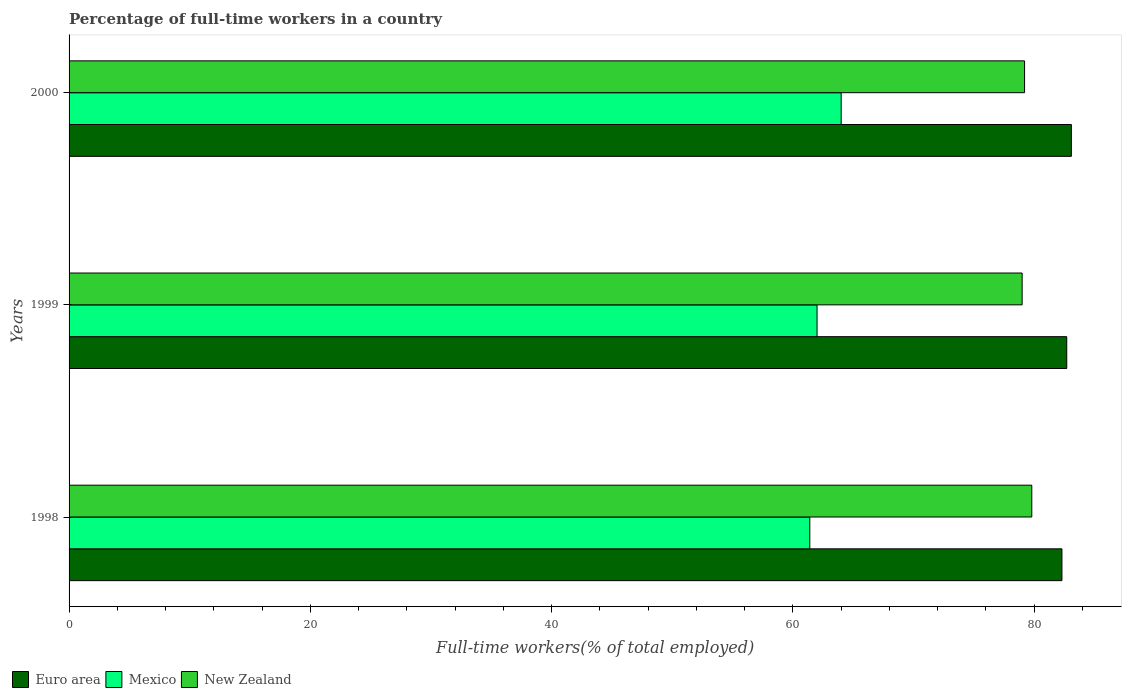Are the number of bars per tick equal to the number of legend labels?
Ensure brevity in your answer.  Yes. How many bars are there on the 3rd tick from the top?
Provide a short and direct response. 3. How many bars are there on the 2nd tick from the bottom?
Offer a very short reply. 3. What is the label of the 3rd group of bars from the top?
Ensure brevity in your answer.  1998. In how many cases, is the number of bars for a given year not equal to the number of legend labels?
Provide a short and direct response. 0. What is the percentage of full-time workers in New Zealand in 2000?
Provide a short and direct response. 79.2. Across all years, what is the maximum percentage of full-time workers in Euro area?
Your answer should be very brief. 83.08. Across all years, what is the minimum percentage of full-time workers in Mexico?
Your answer should be compact. 61.4. In which year was the percentage of full-time workers in New Zealand maximum?
Your answer should be compact. 1998. In which year was the percentage of full-time workers in Euro area minimum?
Your answer should be compact. 1998. What is the total percentage of full-time workers in Euro area in the graph?
Keep it short and to the point. 248.08. What is the difference between the percentage of full-time workers in Mexico in 1998 and that in 1999?
Ensure brevity in your answer.  -0.6. What is the difference between the percentage of full-time workers in Euro area in 2000 and the percentage of full-time workers in Mexico in 1999?
Keep it short and to the point. 21.08. What is the average percentage of full-time workers in New Zealand per year?
Ensure brevity in your answer.  79.33. In the year 1999, what is the difference between the percentage of full-time workers in Euro area and percentage of full-time workers in New Zealand?
Make the answer very short. 3.7. What is the ratio of the percentage of full-time workers in Euro area in 1998 to that in 2000?
Provide a succinct answer. 0.99. What is the difference between the highest and the second highest percentage of full-time workers in New Zealand?
Your answer should be very brief. 0.6. What is the difference between the highest and the lowest percentage of full-time workers in New Zealand?
Offer a terse response. 0.8. Is the sum of the percentage of full-time workers in Mexico in 1998 and 1999 greater than the maximum percentage of full-time workers in Euro area across all years?
Your response must be concise. Yes. Are all the bars in the graph horizontal?
Offer a terse response. Yes. How many years are there in the graph?
Offer a very short reply. 3. Does the graph contain any zero values?
Offer a terse response. No. Where does the legend appear in the graph?
Offer a terse response. Bottom left. What is the title of the graph?
Offer a terse response. Percentage of full-time workers in a country. Does "Euro area" appear as one of the legend labels in the graph?
Your response must be concise. Yes. What is the label or title of the X-axis?
Ensure brevity in your answer.  Full-time workers(% of total employed). What is the Full-time workers(% of total employed) of Euro area in 1998?
Your answer should be very brief. 82.3. What is the Full-time workers(% of total employed) in Mexico in 1998?
Provide a short and direct response. 61.4. What is the Full-time workers(% of total employed) in New Zealand in 1998?
Your answer should be very brief. 79.8. What is the Full-time workers(% of total employed) of Euro area in 1999?
Your answer should be very brief. 82.7. What is the Full-time workers(% of total employed) in New Zealand in 1999?
Your answer should be very brief. 79. What is the Full-time workers(% of total employed) of Euro area in 2000?
Your response must be concise. 83.08. What is the Full-time workers(% of total employed) in Mexico in 2000?
Give a very brief answer. 64. What is the Full-time workers(% of total employed) in New Zealand in 2000?
Your answer should be compact. 79.2. Across all years, what is the maximum Full-time workers(% of total employed) in Euro area?
Your response must be concise. 83.08. Across all years, what is the maximum Full-time workers(% of total employed) in Mexico?
Make the answer very short. 64. Across all years, what is the maximum Full-time workers(% of total employed) of New Zealand?
Offer a very short reply. 79.8. Across all years, what is the minimum Full-time workers(% of total employed) in Euro area?
Your response must be concise. 82.3. Across all years, what is the minimum Full-time workers(% of total employed) in Mexico?
Your response must be concise. 61.4. Across all years, what is the minimum Full-time workers(% of total employed) in New Zealand?
Provide a short and direct response. 79. What is the total Full-time workers(% of total employed) of Euro area in the graph?
Make the answer very short. 248.08. What is the total Full-time workers(% of total employed) of Mexico in the graph?
Your answer should be very brief. 187.4. What is the total Full-time workers(% of total employed) of New Zealand in the graph?
Give a very brief answer. 238. What is the difference between the Full-time workers(% of total employed) of Euro area in 1998 and that in 1999?
Ensure brevity in your answer.  -0.4. What is the difference between the Full-time workers(% of total employed) in New Zealand in 1998 and that in 1999?
Your answer should be very brief. 0.8. What is the difference between the Full-time workers(% of total employed) of Euro area in 1998 and that in 2000?
Your answer should be compact. -0.78. What is the difference between the Full-time workers(% of total employed) in Mexico in 1998 and that in 2000?
Your answer should be very brief. -2.6. What is the difference between the Full-time workers(% of total employed) in New Zealand in 1998 and that in 2000?
Provide a succinct answer. 0.6. What is the difference between the Full-time workers(% of total employed) of Euro area in 1999 and that in 2000?
Provide a succinct answer. -0.38. What is the difference between the Full-time workers(% of total employed) in New Zealand in 1999 and that in 2000?
Offer a terse response. -0.2. What is the difference between the Full-time workers(% of total employed) in Euro area in 1998 and the Full-time workers(% of total employed) in Mexico in 1999?
Your answer should be very brief. 20.3. What is the difference between the Full-time workers(% of total employed) in Euro area in 1998 and the Full-time workers(% of total employed) in New Zealand in 1999?
Give a very brief answer. 3.3. What is the difference between the Full-time workers(% of total employed) of Mexico in 1998 and the Full-time workers(% of total employed) of New Zealand in 1999?
Your answer should be compact. -17.6. What is the difference between the Full-time workers(% of total employed) in Euro area in 1998 and the Full-time workers(% of total employed) in Mexico in 2000?
Keep it short and to the point. 18.3. What is the difference between the Full-time workers(% of total employed) of Euro area in 1998 and the Full-time workers(% of total employed) of New Zealand in 2000?
Offer a terse response. 3.1. What is the difference between the Full-time workers(% of total employed) in Mexico in 1998 and the Full-time workers(% of total employed) in New Zealand in 2000?
Your answer should be very brief. -17.8. What is the difference between the Full-time workers(% of total employed) in Euro area in 1999 and the Full-time workers(% of total employed) in Mexico in 2000?
Your answer should be very brief. 18.7. What is the difference between the Full-time workers(% of total employed) in Euro area in 1999 and the Full-time workers(% of total employed) in New Zealand in 2000?
Provide a short and direct response. 3.5. What is the difference between the Full-time workers(% of total employed) in Mexico in 1999 and the Full-time workers(% of total employed) in New Zealand in 2000?
Your answer should be compact. -17.2. What is the average Full-time workers(% of total employed) of Euro area per year?
Keep it short and to the point. 82.69. What is the average Full-time workers(% of total employed) in Mexico per year?
Your response must be concise. 62.47. What is the average Full-time workers(% of total employed) of New Zealand per year?
Make the answer very short. 79.33. In the year 1998, what is the difference between the Full-time workers(% of total employed) of Euro area and Full-time workers(% of total employed) of Mexico?
Ensure brevity in your answer.  20.9. In the year 1998, what is the difference between the Full-time workers(% of total employed) in Euro area and Full-time workers(% of total employed) in New Zealand?
Ensure brevity in your answer.  2.5. In the year 1998, what is the difference between the Full-time workers(% of total employed) in Mexico and Full-time workers(% of total employed) in New Zealand?
Keep it short and to the point. -18.4. In the year 1999, what is the difference between the Full-time workers(% of total employed) of Euro area and Full-time workers(% of total employed) of Mexico?
Make the answer very short. 20.7. In the year 1999, what is the difference between the Full-time workers(% of total employed) in Euro area and Full-time workers(% of total employed) in New Zealand?
Ensure brevity in your answer.  3.7. In the year 1999, what is the difference between the Full-time workers(% of total employed) in Mexico and Full-time workers(% of total employed) in New Zealand?
Provide a short and direct response. -17. In the year 2000, what is the difference between the Full-time workers(% of total employed) of Euro area and Full-time workers(% of total employed) of Mexico?
Keep it short and to the point. 19.08. In the year 2000, what is the difference between the Full-time workers(% of total employed) in Euro area and Full-time workers(% of total employed) in New Zealand?
Ensure brevity in your answer.  3.88. In the year 2000, what is the difference between the Full-time workers(% of total employed) of Mexico and Full-time workers(% of total employed) of New Zealand?
Keep it short and to the point. -15.2. What is the ratio of the Full-time workers(% of total employed) of Euro area in 1998 to that in 1999?
Provide a succinct answer. 1. What is the ratio of the Full-time workers(% of total employed) of Mexico in 1998 to that in 1999?
Provide a short and direct response. 0.99. What is the ratio of the Full-time workers(% of total employed) of Euro area in 1998 to that in 2000?
Make the answer very short. 0.99. What is the ratio of the Full-time workers(% of total employed) in Mexico in 1998 to that in 2000?
Ensure brevity in your answer.  0.96. What is the ratio of the Full-time workers(% of total employed) of New Zealand in 1998 to that in 2000?
Your answer should be compact. 1.01. What is the ratio of the Full-time workers(% of total employed) in Euro area in 1999 to that in 2000?
Provide a short and direct response. 1. What is the ratio of the Full-time workers(% of total employed) of Mexico in 1999 to that in 2000?
Keep it short and to the point. 0.97. What is the ratio of the Full-time workers(% of total employed) of New Zealand in 1999 to that in 2000?
Your answer should be very brief. 1. What is the difference between the highest and the second highest Full-time workers(% of total employed) in Euro area?
Offer a terse response. 0.38. What is the difference between the highest and the lowest Full-time workers(% of total employed) of Euro area?
Provide a succinct answer. 0.78. What is the difference between the highest and the lowest Full-time workers(% of total employed) in Mexico?
Your answer should be compact. 2.6. What is the difference between the highest and the lowest Full-time workers(% of total employed) of New Zealand?
Keep it short and to the point. 0.8. 